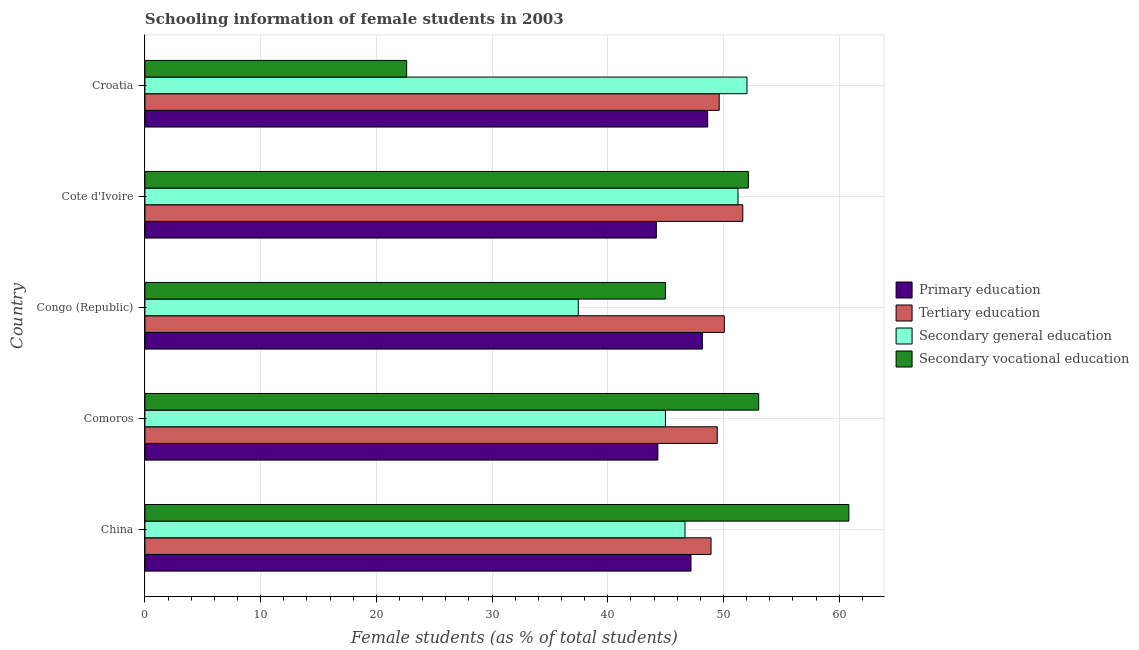How many groups of bars are there?
Your answer should be very brief. 5. Are the number of bars on each tick of the Y-axis equal?
Give a very brief answer. Yes. How many bars are there on the 1st tick from the top?
Provide a short and direct response. 4. How many bars are there on the 2nd tick from the bottom?
Your answer should be compact. 4. What is the percentage of female students in secondary education in Congo (Republic)?
Offer a very short reply. 37.45. Across all countries, what is the maximum percentage of female students in tertiary education?
Keep it short and to the point. 51.67. Across all countries, what is the minimum percentage of female students in secondary education?
Make the answer very short. 37.45. In which country was the percentage of female students in tertiary education maximum?
Keep it short and to the point. Cote d'Ivoire. In which country was the percentage of female students in secondary education minimum?
Provide a succinct answer. Congo (Republic). What is the total percentage of female students in secondary education in the graph?
Ensure brevity in your answer.  232.4. What is the difference between the percentage of female students in secondary vocational education in Congo (Republic) and that in Cote d'Ivoire?
Keep it short and to the point. -7.17. What is the difference between the percentage of female students in secondary education in Croatia and the percentage of female students in tertiary education in Comoros?
Your answer should be very brief. 2.57. What is the average percentage of female students in tertiary education per country?
Ensure brevity in your answer.  49.95. What is the difference between the percentage of female students in secondary education and percentage of female students in tertiary education in China?
Give a very brief answer. -2.25. In how many countries, is the percentage of female students in primary education greater than 6 %?
Your answer should be very brief. 5. What is the difference between the highest and the second highest percentage of female students in tertiary education?
Provide a short and direct response. 1.6. What is the difference between the highest and the lowest percentage of female students in tertiary education?
Make the answer very short. 2.74. In how many countries, is the percentage of female students in tertiary education greater than the average percentage of female students in tertiary education taken over all countries?
Your answer should be very brief. 2. Is the sum of the percentage of female students in tertiary education in Congo (Republic) and Cote d'Ivoire greater than the maximum percentage of female students in secondary vocational education across all countries?
Make the answer very short. Yes. Is it the case that in every country, the sum of the percentage of female students in secondary vocational education and percentage of female students in primary education is greater than the sum of percentage of female students in tertiary education and percentage of female students in secondary education?
Your answer should be compact. Yes. What does the 4th bar from the top in Congo (Republic) represents?
Your answer should be compact. Primary education. What does the 1st bar from the bottom in Croatia represents?
Offer a very short reply. Primary education. Is it the case that in every country, the sum of the percentage of female students in primary education and percentage of female students in tertiary education is greater than the percentage of female students in secondary education?
Provide a short and direct response. Yes. Are all the bars in the graph horizontal?
Offer a terse response. Yes. What is the difference between two consecutive major ticks on the X-axis?
Your response must be concise. 10. Does the graph contain grids?
Your answer should be very brief. Yes. Where does the legend appear in the graph?
Provide a short and direct response. Center right. What is the title of the graph?
Keep it short and to the point. Schooling information of female students in 2003. Does "Austria" appear as one of the legend labels in the graph?
Offer a very short reply. No. What is the label or title of the X-axis?
Ensure brevity in your answer.  Female students (as % of total students). What is the Female students (as % of total students) of Primary education in China?
Provide a short and direct response. 47.19. What is the Female students (as % of total students) of Tertiary education in China?
Keep it short and to the point. 48.93. What is the Female students (as % of total students) in Secondary general education in China?
Provide a short and direct response. 46.68. What is the Female students (as % of total students) in Secondary vocational education in China?
Provide a short and direct response. 60.84. What is the Female students (as % of total students) in Primary education in Comoros?
Keep it short and to the point. 44.33. What is the Female students (as % of total students) of Tertiary education in Comoros?
Offer a terse response. 49.46. What is the Female students (as % of total students) in Secondary general education in Comoros?
Offer a terse response. 44.99. What is the Female students (as % of total students) of Secondary vocational education in Comoros?
Keep it short and to the point. 53.04. What is the Female students (as % of total students) in Primary education in Congo (Republic)?
Offer a terse response. 48.18. What is the Female students (as % of total students) of Tertiary education in Congo (Republic)?
Your answer should be very brief. 50.07. What is the Female students (as % of total students) in Secondary general education in Congo (Republic)?
Your answer should be very brief. 37.45. What is the Female students (as % of total students) of Secondary vocational education in Congo (Republic)?
Provide a succinct answer. 44.98. What is the Female students (as % of total students) of Primary education in Cote d'Ivoire?
Ensure brevity in your answer.  44.2. What is the Female students (as % of total students) of Tertiary education in Cote d'Ivoire?
Give a very brief answer. 51.67. What is the Female students (as % of total students) in Secondary general education in Cote d'Ivoire?
Your answer should be compact. 51.26. What is the Female students (as % of total students) of Secondary vocational education in Cote d'Ivoire?
Your response must be concise. 52.15. What is the Female students (as % of total students) in Primary education in Croatia?
Provide a succinct answer. 48.63. What is the Female students (as % of total students) of Tertiary education in Croatia?
Ensure brevity in your answer.  49.63. What is the Female students (as % of total students) of Secondary general education in Croatia?
Your answer should be compact. 52.03. What is the Female students (as % of total students) of Secondary vocational education in Croatia?
Your response must be concise. 22.62. Across all countries, what is the maximum Female students (as % of total students) in Primary education?
Offer a terse response. 48.63. Across all countries, what is the maximum Female students (as % of total students) of Tertiary education?
Your answer should be very brief. 51.67. Across all countries, what is the maximum Female students (as % of total students) of Secondary general education?
Your answer should be very brief. 52.03. Across all countries, what is the maximum Female students (as % of total students) of Secondary vocational education?
Give a very brief answer. 60.84. Across all countries, what is the minimum Female students (as % of total students) in Primary education?
Provide a short and direct response. 44.2. Across all countries, what is the minimum Female students (as % of total students) in Tertiary education?
Give a very brief answer. 48.93. Across all countries, what is the minimum Female students (as % of total students) in Secondary general education?
Offer a very short reply. 37.45. Across all countries, what is the minimum Female students (as % of total students) of Secondary vocational education?
Keep it short and to the point. 22.62. What is the total Female students (as % of total students) in Primary education in the graph?
Your answer should be very brief. 232.53. What is the total Female students (as % of total students) in Tertiary education in the graph?
Your answer should be very brief. 249.76. What is the total Female students (as % of total students) of Secondary general education in the graph?
Provide a short and direct response. 232.4. What is the total Female students (as % of total students) in Secondary vocational education in the graph?
Ensure brevity in your answer.  233.64. What is the difference between the Female students (as % of total students) in Primary education in China and that in Comoros?
Provide a short and direct response. 2.86. What is the difference between the Female students (as % of total students) in Tertiary education in China and that in Comoros?
Keep it short and to the point. -0.54. What is the difference between the Female students (as % of total students) of Secondary general education in China and that in Comoros?
Provide a short and direct response. 1.69. What is the difference between the Female students (as % of total students) in Secondary vocational education in China and that in Comoros?
Your response must be concise. 7.79. What is the difference between the Female students (as % of total students) in Primary education in China and that in Congo (Republic)?
Give a very brief answer. -0.98. What is the difference between the Female students (as % of total students) of Tertiary education in China and that in Congo (Republic)?
Ensure brevity in your answer.  -1.15. What is the difference between the Female students (as % of total students) in Secondary general education in China and that in Congo (Republic)?
Offer a terse response. 9.22. What is the difference between the Female students (as % of total students) of Secondary vocational education in China and that in Congo (Republic)?
Provide a short and direct response. 15.85. What is the difference between the Female students (as % of total students) in Primary education in China and that in Cote d'Ivoire?
Provide a short and direct response. 2.99. What is the difference between the Female students (as % of total students) of Tertiary education in China and that in Cote d'Ivoire?
Your answer should be very brief. -2.74. What is the difference between the Female students (as % of total students) of Secondary general education in China and that in Cote d'Ivoire?
Keep it short and to the point. -4.58. What is the difference between the Female students (as % of total students) in Secondary vocational education in China and that in Cote d'Ivoire?
Offer a terse response. 8.68. What is the difference between the Female students (as % of total students) in Primary education in China and that in Croatia?
Provide a short and direct response. -1.44. What is the difference between the Female students (as % of total students) in Tertiary education in China and that in Croatia?
Offer a very short reply. -0.7. What is the difference between the Female students (as % of total students) of Secondary general education in China and that in Croatia?
Make the answer very short. -5.36. What is the difference between the Female students (as % of total students) of Secondary vocational education in China and that in Croatia?
Your response must be concise. 38.22. What is the difference between the Female students (as % of total students) in Primary education in Comoros and that in Congo (Republic)?
Provide a short and direct response. -3.85. What is the difference between the Female students (as % of total students) in Tertiary education in Comoros and that in Congo (Republic)?
Keep it short and to the point. -0.61. What is the difference between the Female students (as % of total students) of Secondary general education in Comoros and that in Congo (Republic)?
Your answer should be compact. 7.53. What is the difference between the Female students (as % of total students) of Secondary vocational education in Comoros and that in Congo (Republic)?
Give a very brief answer. 8.06. What is the difference between the Female students (as % of total students) in Primary education in Comoros and that in Cote d'Ivoire?
Offer a terse response. 0.13. What is the difference between the Female students (as % of total students) of Tertiary education in Comoros and that in Cote d'Ivoire?
Keep it short and to the point. -2.21. What is the difference between the Female students (as % of total students) in Secondary general education in Comoros and that in Cote d'Ivoire?
Provide a succinct answer. -6.27. What is the difference between the Female students (as % of total students) of Secondary vocational education in Comoros and that in Cote d'Ivoire?
Your response must be concise. 0.89. What is the difference between the Female students (as % of total students) of Primary education in Comoros and that in Croatia?
Your answer should be very brief. -4.3. What is the difference between the Female students (as % of total students) in Tertiary education in Comoros and that in Croatia?
Provide a succinct answer. -0.17. What is the difference between the Female students (as % of total students) of Secondary general education in Comoros and that in Croatia?
Your answer should be compact. -7.05. What is the difference between the Female students (as % of total students) in Secondary vocational education in Comoros and that in Croatia?
Offer a very short reply. 30.42. What is the difference between the Female students (as % of total students) of Primary education in Congo (Republic) and that in Cote d'Ivoire?
Provide a short and direct response. 3.98. What is the difference between the Female students (as % of total students) of Tertiary education in Congo (Republic) and that in Cote d'Ivoire?
Give a very brief answer. -1.6. What is the difference between the Female students (as % of total students) of Secondary general education in Congo (Republic) and that in Cote d'Ivoire?
Give a very brief answer. -13.8. What is the difference between the Female students (as % of total students) of Secondary vocational education in Congo (Republic) and that in Cote d'Ivoire?
Make the answer very short. -7.17. What is the difference between the Female students (as % of total students) in Primary education in Congo (Republic) and that in Croatia?
Provide a succinct answer. -0.46. What is the difference between the Female students (as % of total students) of Tertiary education in Congo (Republic) and that in Croatia?
Make the answer very short. 0.44. What is the difference between the Female students (as % of total students) in Secondary general education in Congo (Republic) and that in Croatia?
Your answer should be very brief. -14.58. What is the difference between the Female students (as % of total students) in Secondary vocational education in Congo (Republic) and that in Croatia?
Provide a succinct answer. 22.36. What is the difference between the Female students (as % of total students) in Primary education in Cote d'Ivoire and that in Croatia?
Make the answer very short. -4.43. What is the difference between the Female students (as % of total students) in Tertiary education in Cote d'Ivoire and that in Croatia?
Make the answer very short. 2.04. What is the difference between the Female students (as % of total students) in Secondary general education in Cote d'Ivoire and that in Croatia?
Give a very brief answer. -0.78. What is the difference between the Female students (as % of total students) of Secondary vocational education in Cote d'Ivoire and that in Croatia?
Your answer should be compact. 29.54. What is the difference between the Female students (as % of total students) in Primary education in China and the Female students (as % of total students) in Tertiary education in Comoros?
Your answer should be compact. -2.27. What is the difference between the Female students (as % of total students) in Primary education in China and the Female students (as % of total students) in Secondary general education in Comoros?
Make the answer very short. 2.21. What is the difference between the Female students (as % of total students) in Primary education in China and the Female students (as % of total students) in Secondary vocational education in Comoros?
Your answer should be very brief. -5.85. What is the difference between the Female students (as % of total students) in Tertiary education in China and the Female students (as % of total students) in Secondary general education in Comoros?
Ensure brevity in your answer.  3.94. What is the difference between the Female students (as % of total students) in Tertiary education in China and the Female students (as % of total students) in Secondary vocational education in Comoros?
Your response must be concise. -4.12. What is the difference between the Female students (as % of total students) in Secondary general education in China and the Female students (as % of total students) in Secondary vocational education in Comoros?
Provide a succinct answer. -6.37. What is the difference between the Female students (as % of total students) in Primary education in China and the Female students (as % of total students) in Tertiary education in Congo (Republic)?
Ensure brevity in your answer.  -2.88. What is the difference between the Female students (as % of total students) of Primary education in China and the Female students (as % of total students) of Secondary general education in Congo (Republic)?
Your answer should be compact. 9.74. What is the difference between the Female students (as % of total students) of Primary education in China and the Female students (as % of total students) of Secondary vocational education in Congo (Republic)?
Your response must be concise. 2.21. What is the difference between the Female students (as % of total students) of Tertiary education in China and the Female students (as % of total students) of Secondary general education in Congo (Republic)?
Provide a succinct answer. 11.47. What is the difference between the Female students (as % of total students) in Tertiary education in China and the Female students (as % of total students) in Secondary vocational education in Congo (Republic)?
Ensure brevity in your answer.  3.94. What is the difference between the Female students (as % of total students) of Secondary general education in China and the Female students (as % of total students) of Secondary vocational education in Congo (Republic)?
Keep it short and to the point. 1.69. What is the difference between the Female students (as % of total students) of Primary education in China and the Female students (as % of total students) of Tertiary education in Cote d'Ivoire?
Keep it short and to the point. -4.48. What is the difference between the Female students (as % of total students) in Primary education in China and the Female students (as % of total students) in Secondary general education in Cote d'Ivoire?
Provide a short and direct response. -4.06. What is the difference between the Female students (as % of total students) of Primary education in China and the Female students (as % of total students) of Secondary vocational education in Cote d'Ivoire?
Give a very brief answer. -4.96. What is the difference between the Female students (as % of total students) in Tertiary education in China and the Female students (as % of total students) in Secondary general education in Cote d'Ivoire?
Your response must be concise. -2.33. What is the difference between the Female students (as % of total students) of Tertiary education in China and the Female students (as % of total students) of Secondary vocational education in Cote d'Ivoire?
Provide a short and direct response. -3.23. What is the difference between the Female students (as % of total students) of Secondary general education in China and the Female students (as % of total students) of Secondary vocational education in Cote d'Ivoire?
Make the answer very short. -5.48. What is the difference between the Female students (as % of total students) of Primary education in China and the Female students (as % of total students) of Tertiary education in Croatia?
Provide a short and direct response. -2.44. What is the difference between the Female students (as % of total students) of Primary education in China and the Female students (as % of total students) of Secondary general education in Croatia?
Offer a very short reply. -4.84. What is the difference between the Female students (as % of total students) of Primary education in China and the Female students (as % of total students) of Secondary vocational education in Croatia?
Offer a terse response. 24.57. What is the difference between the Female students (as % of total students) in Tertiary education in China and the Female students (as % of total students) in Secondary general education in Croatia?
Your answer should be very brief. -3.1. What is the difference between the Female students (as % of total students) of Tertiary education in China and the Female students (as % of total students) of Secondary vocational education in Croatia?
Make the answer very short. 26.31. What is the difference between the Female students (as % of total students) of Secondary general education in China and the Female students (as % of total students) of Secondary vocational education in Croatia?
Make the answer very short. 24.06. What is the difference between the Female students (as % of total students) of Primary education in Comoros and the Female students (as % of total students) of Tertiary education in Congo (Republic)?
Ensure brevity in your answer.  -5.74. What is the difference between the Female students (as % of total students) of Primary education in Comoros and the Female students (as % of total students) of Secondary general education in Congo (Republic)?
Provide a short and direct response. 6.88. What is the difference between the Female students (as % of total students) in Primary education in Comoros and the Female students (as % of total students) in Secondary vocational education in Congo (Republic)?
Offer a terse response. -0.65. What is the difference between the Female students (as % of total students) of Tertiary education in Comoros and the Female students (as % of total students) of Secondary general education in Congo (Republic)?
Offer a terse response. 12.01. What is the difference between the Female students (as % of total students) of Tertiary education in Comoros and the Female students (as % of total students) of Secondary vocational education in Congo (Republic)?
Offer a terse response. 4.48. What is the difference between the Female students (as % of total students) in Secondary general education in Comoros and the Female students (as % of total students) in Secondary vocational education in Congo (Republic)?
Offer a terse response. 0. What is the difference between the Female students (as % of total students) of Primary education in Comoros and the Female students (as % of total students) of Tertiary education in Cote d'Ivoire?
Offer a very short reply. -7.34. What is the difference between the Female students (as % of total students) in Primary education in Comoros and the Female students (as % of total students) in Secondary general education in Cote d'Ivoire?
Your response must be concise. -6.92. What is the difference between the Female students (as % of total students) in Primary education in Comoros and the Female students (as % of total students) in Secondary vocational education in Cote d'Ivoire?
Provide a succinct answer. -7.82. What is the difference between the Female students (as % of total students) of Tertiary education in Comoros and the Female students (as % of total students) of Secondary general education in Cote d'Ivoire?
Your answer should be very brief. -1.79. What is the difference between the Female students (as % of total students) of Tertiary education in Comoros and the Female students (as % of total students) of Secondary vocational education in Cote d'Ivoire?
Ensure brevity in your answer.  -2.69. What is the difference between the Female students (as % of total students) of Secondary general education in Comoros and the Female students (as % of total students) of Secondary vocational education in Cote d'Ivoire?
Offer a very short reply. -7.17. What is the difference between the Female students (as % of total students) of Primary education in Comoros and the Female students (as % of total students) of Secondary general education in Croatia?
Ensure brevity in your answer.  -7.7. What is the difference between the Female students (as % of total students) in Primary education in Comoros and the Female students (as % of total students) in Secondary vocational education in Croatia?
Offer a terse response. 21.71. What is the difference between the Female students (as % of total students) of Tertiary education in Comoros and the Female students (as % of total students) of Secondary general education in Croatia?
Provide a short and direct response. -2.57. What is the difference between the Female students (as % of total students) of Tertiary education in Comoros and the Female students (as % of total students) of Secondary vocational education in Croatia?
Offer a very short reply. 26.84. What is the difference between the Female students (as % of total students) in Secondary general education in Comoros and the Female students (as % of total students) in Secondary vocational education in Croatia?
Make the answer very short. 22.37. What is the difference between the Female students (as % of total students) of Primary education in Congo (Republic) and the Female students (as % of total students) of Tertiary education in Cote d'Ivoire?
Make the answer very short. -3.49. What is the difference between the Female students (as % of total students) in Primary education in Congo (Republic) and the Female students (as % of total students) in Secondary general education in Cote d'Ivoire?
Give a very brief answer. -3.08. What is the difference between the Female students (as % of total students) in Primary education in Congo (Republic) and the Female students (as % of total students) in Secondary vocational education in Cote d'Ivoire?
Your answer should be very brief. -3.98. What is the difference between the Female students (as % of total students) of Tertiary education in Congo (Republic) and the Female students (as % of total students) of Secondary general education in Cote d'Ivoire?
Keep it short and to the point. -1.18. What is the difference between the Female students (as % of total students) in Tertiary education in Congo (Republic) and the Female students (as % of total students) in Secondary vocational education in Cote d'Ivoire?
Give a very brief answer. -2.08. What is the difference between the Female students (as % of total students) of Secondary general education in Congo (Republic) and the Female students (as % of total students) of Secondary vocational education in Cote d'Ivoire?
Provide a succinct answer. -14.7. What is the difference between the Female students (as % of total students) of Primary education in Congo (Republic) and the Female students (as % of total students) of Tertiary education in Croatia?
Provide a short and direct response. -1.45. What is the difference between the Female students (as % of total students) of Primary education in Congo (Republic) and the Female students (as % of total students) of Secondary general education in Croatia?
Your answer should be compact. -3.86. What is the difference between the Female students (as % of total students) in Primary education in Congo (Republic) and the Female students (as % of total students) in Secondary vocational education in Croatia?
Provide a succinct answer. 25.56. What is the difference between the Female students (as % of total students) in Tertiary education in Congo (Republic) and the Female students (as % of total students) in Secondary general education in Croatia?
Keep it short and to the point. -1.96. What is the difference between the Female students (as % of total students) of Tertiary education in Congo (Republic) and the Female students (as % of total students) of Secondary vocational education in Croatia?
Make the answer very short. 27.45. What is the difference between the Female students (as % of total students) of Secondary general education in Congo (Republic) and the Female students (as % of total students) of Secondary vocational education in Croatia?
Provide a short and direct response. 14.83. What is the difference between the Female students (as % of total students) in Primary education in Cote d'Ivoire and the Female students (as % of total students) in Tertiary education in Croatia?
Your answer should be very brief. -5.43. What is the difference between the Female students (as % of total students) in Primary education in Cote d'Ivoire and the Female students (as % of total students) in Secondary general education in Croatia?
Your answer should be very brief. -7.83. What is the difference between the Female students (as % of total students) in Primary education in Cote d'Ivoire and the Female students (as % of total students) in Secondary vocational education in Croatia?
Give a very brief answer. 21.58. What is the difference between the Female students (as % of total students) in Tertiary education in Cote d'Ivoire and the Female students (as % of total students) in Secondary general education in Croatia?
Your answer should be very brief. -0.36. What is the difference between the Female students (as % of total students) of Tertiary education in Cote d'Ivoire and the Female students (as % of total students) of Secondary vocational education in Croatia?
Give a very brief answer. 29.05. What is the difference between the Female students (as % of total students) in Secondary general education in Cote d'Ivoire and the Female students (as % of total students) in Secondary vocational education in Croatia?
Your answer should be compact. 28.64. What is the average Female students (as % of total students) of Primary education per country?
Ensure brevity in your answer.  46.51. What is the average Female students (as % of total students) of Tertiary education per country?
Keep it short and to the point. 49.95. What is the average Female students (as % of total students) in Secondary general education per country?
Ensure brevity in your answer.  46.48. What is the average Female students (as % of total students) in Secondary vocational education per country?
Your answer should be very brief. 46.73. What is the difference between the Female students (as % of total students) in Primary education and Female students (as % of total students) in Tertiary education in China?
Provide a short and direct response. -1.74. What is the difference between the Female students (as % of total students) of Primary education and Female students (as % of total students) of Secondary general education in China?
Your answer should be very brief. 0.51. What is the difference between the Female students (as % of total students) of Primary education and Female students (as % of total students) of Secondary vocational education in China?
Provide a short and direct response. -13.65. What is the difference between the Female students (as % of total students) in Tertiary education and Female students (as % of total students) in Secondary general education in China?
Give a very brief answer. 2.25. What is the difference between the Female students (as % of total students) of Tertiary education and Female students (as % of total students) of Secondary vocational education in China?
Give a very brief answer. -11.91. What is the difference between the Female students (as % of total students) in Secondary general education and Female students (as % of total students) in Secondary vocational education in China?
Offer a terse response. -14.16. What is the difference between the Female students (as % of total students) of Primary education and Female students (as % of total students) of Tertiary education in Comoros?
Ensure brevity in your answer.  -5.13. What is the difference between the Female students (as % of total students) in Primary education and Female students (as % of total students) in Secondary general education in Comoros?
Make the answer very short. -0.66. What is the difference between the Female students (as % of total students) in Primary education and Female students (as % of total students) in Secondary vocational education in Comoros?
Provide a short and direct response. -8.71. What is the difference between the Female students (as % of total students) of Tertiary education and Female students (as % of total students) of Secondary general education in Comoros?
Offer a terse response. 4.48. What is the difference between the Female students (as % of total students) in Tertiary education and Female students (as % of total students) in Secondary vocational education in Comoros?
Provide a succinct answer. -3.58. What is the difference between the Female students (as % of total students) in Secondary general education and Female students (as % of total students) in Secondary vocational education in Comoros?
Make the answer very short. -8.06. What is the difference between the Female students (as % of total students) of Primary education and Female students (as % of total students) of Tertiary education in Congo (Republic)?
Provide a succinct answer. -1.9. What is the difference between the Female students (as % of total students) of Primary education and Female students (as % of total students) of Secondary general education in Congo (Republic)?
Provide a short and direct response. 10.72. What is the difference between the Female students (as % of total students) of Primary education and Female students (as % of total students) of Secondary vocational education in Congo (Republic)?
Your response must be concise. 3.19. What is the difference between the Female students (as % of total students) of Tertiary education and Female students (as % of total students) of Secondary general education in Congo (Republic)?
Provide a short and direct response. 12.62. What is the difference between the Female students (as % of total students) of Tertiary education and Female students (as % of total students) of Secondary vocational education in Congo (Republic)?
Provide a succinct answer. 5.09. What is the difference between the Female students (as % of total students) of Secondary general education and Female students (as % of total students) of Secondary vocational education in Congo (Republic)?
Your response must be concise. -7.53. What is the difference between the Female students (as % of total students) in Primary education and Female students (as % of total students) in Tertiary education in Cote d'Ivoire?
Ensure brevity in your answer.  -7.47. What is the difference between the Female students (as % of total students) of Primary education and Female students (as % of total students) of Secondary general education in Cote d'Ivoire?
Make the answer very short. -7.06. What is the difference between the Female students (as % of total students) of Primary education and Female students (as % of total students) of Secondary vocational education in Cote d'Ivoire?
Keep it short and to the point. -7.96. What is the difference between the Female students (as % of total students) in Tertiary education and Female students (as % of total students) in Secondary general education in Cote d'Ivoire?
Your answer should be compact. 0.41. What is the difference between the Female students (as % of total students) in Tertiary education and Female students (as % of total students) in Secondary vocational education in Cote d'Ivoire?
Make the answer very short. -0.48. What is the difference between the Female students (as % of total students) in Secondary general education and Female students (as % of total students) in Secondary vocational education in Cote d'Ivoire?
Provide a succinct answer. -0.9. What is the difference between the Female students (as % of total students) in Primary education and Female students (as % of total students) in Tertiary education in Croatia?
Ensure brevity in your answer.  -1. What is the difference between the Female students (as % of total students) of Primary education and Female students (as % of total students) of Secondary general education in Croatia?
Your answer should be compact. -3.4. What is the difference between the Female students (as % of total students) in Primary education and Female students (as % of total students) in Secondary vocational education in Croatia?
Offer a very short reply. 26.01. What is the difference between the Female students (as % of total students) of Tertiary education and Female students (as % of total students) of Secondary general education in Croatia?
Provide a succinct answer. -2.4. What is the difference between the Female students (as % of total students) of Tertiary education and Female students (as % of total students) of Secondary vocational education in Croatia?
Provide a succinct answer. 27.01. What is the difference between the Female students (as % of total students) in Secondary general education and Female students (as % of total students) in Secondary vocational education in Croatia?
Ensure brevity in your answer.  29.41. What is the ratio of the Female students (as % of total students) in Primary education in China to that in Comoros?
Offer a terse response. 1.06. What is the ratio of the Female students (as % of total students) of Tertiary education in China to that in Comoros?
Provide a short and direct response. 0.99. What is the ratio of the Female students (as % of total students) in Secondary general education in China to that in Comoros?
Offer a very short reply. 1.04. What is the ratio of the Female students (as % of total students) in Secondary vocational education in China to that in Comoros?
Your answer should be compact. 1.15. What is the ratio of the Female students (as % of total students) in Primary education in China to that in Congo (Republic)?
Provide a succinct answer. 0.98. What is the ratio of the Female students (as % of total students) of Tertiary education in China to that in Congo (Republic)?
Offer a very short reply. 0.98. What is the ratio of the Female students (as % of total students) of Secondary general education in China to that in Congo (Republic)?
Ensure brevity in your answer.  1.25. What is the ratio of the Female students (as % of total students) of Secondary vocational education in China to that in Congo (Republic)?
Provide a succinct answer. 1.35. What is the ratio of the Female students (as % of total students) in Primary education in China to that in Cote d'Ivoire?
Offer a very short reply. 1.07. What is the ratio of the Female students (as % of total students) of Tertiary education in China to that in Cote d'Ivoire?
Provide a short and direct response. 0.95. What is the ratio of the Female students (as % of total students) of Secondary general education in China to that in Cote d'Ivoire?
Offer a terse response. 0.91. What is the ratio of the Female students (as % of total students) in Secondary vocational education in China to that in Cote d'Ivoire?
Offer a very short reply. 1.17. What is the ratio of the Female students (as % of total students) of Primary education in China to that in Croatia?
Your answer should be compact. 0.97. What is the ratio of the Female students (as % of total students) of Tertiary education in China to that in Croatia?
Your response must be concise. 0.99. What is the ratio of the Female students (as % of total students) in Secondary general education in China to that in Croatia?
Keep it short and to the point. 0.9. What is the ratio of the Female students (as % of total students) of Secondary vocational education in China to that in Croatia?
Provide a succinct answer. 2.69. What is the ratio of the Female students (as % of total students) in Primary education in Comoros to that in Congo (Republic)?
Make the answer very short. 0.92. What is the ratio of the Female students (as % of total students) in Secondary general education in Comoros to that in Congo (Republic)?
Ensure brevity in your answer.  1.2. What is the ratio of the Female students (as % of total students) of Secondary vocational education in Comoros to that in Congo (Republic)?
Provide a succinct answer. 1.18. What is the ratio of the Female students (as % of total students) in Tertiary education in Comoros to that in Cote d'Ivoire?
Your response must be concise. 0.96. What is the ratio of the Female students (as % of total students) in Secondary general education in Comoros to that in Cote d'Ivoire?
Offer a very short reply. 0.88. What is the ratio of the Female students (as % of total students) of Primary education in Comoros to that in Croatia?
Your answer should be very brief. 0.91. What is the ratio of the Female students (as % of total students) in Tertiary education in Comoros to that in Croatia?
Your response must be concise. 1. What is the ratio of the Female students (as % of total students) in Secondary general education in Comoros to that in Croatia?
Provide a short and direct response. 0.86. What is the ratio of the Female students (as % of total students) in Secondary vocational education in Comoros to that in Croatia?
Your response must be concise. 2.35. What is the ratio of the Female students (as % of total students) of Primary education in Congo (Republic) to that in Cote d'Ivoire?
Your answer should be compact. 1.09. What is the ratio of the Female students (as % of total students) in Tertiary education in Congo (Republic) to that in Cote d'Ivoire?
Your answer should be very brief. 0.97. What is the ratio of the Female students (as % of total students) in Secondary general education in Congo (Republic) to that in Cote d'Ivoire?
Ensure brevity in your answer.  0.73. What is the ratio of the Female students (as % of total students) of Secondary vocational education in Congo (Republic) to that in Cote d'Ivoire?
Your response must be concise. 0.86. What is the ratio of the Female students (as % of total students) in Primary education in Congo (Republic) to that in Croatia?
Offer a terse response. 0.99. What is the ratio of the Female students (as % of total students) of Tertiary education in Congo (Republic) to that in Croatia?
Ensure brevity in your answer.  1.01. What is the ratio of the Female students (as % of total students) of Secondary general education in Congo (Republic) to that in Croatia?
Offer a very short reply. 0.72. What is the ratio of the Female students (as % of total students) of Secondary vocational education in Congo (Republic) to that in Croatia?
Your response must be concise. 1.99. What is the ratio of the Female students (as % of total students) in Primary education in Cote d'Ivoire to that in Croatia?
Keep it short and to the point. 0.91. What is the ratio of the Female students (as % of total students) in Tertiary education in Cote d'Ivoire to that in Croatia?
Your answer should be very brief. 1.04. What is the ratio of the Female students (as % of total students) in Secondary general education in Cote d'Ivoire to that in Croatia?
Your response must be concise. 0.99. What is the ratio of the Female students (as % of total students) in Secondary vocational education in Cote d'Ivoire to that in Croatia?
Your response must be concise. 2.31. What is the difference between the highest and the second highest Female students (as % of total students) of Primary education?
Your answer should be very brief. 0.46. What is the difference between the highest and the second highest Female students (as % of total students) in Tertiary education?
Ensure brevity in your answer.  1.6. What is the difference between the highest and the second highest Female students (as % of total students) of Secondary general education?
Offer a terse response. 0.78. What is the difference between the highest and the second highest Female students (as % of total students) in Secondary vocational education?
Offer a very short reply. 7.79. What is the difference between the highest and the lowest Female students (as % of total students) of Primary education?
Keep it short and to the point. 4.43. What is the difference between the highest and the lowest Female students (as % of total students) of Tertiary education?
Ensure brevity in your answer.  2.74. What is the difference between the highest and the lowest Female students (as % of total students) of Secondary general education?
Make the answer very short. 14.58. What is the difference between the highest and the lowest Female students (as % of total students) in Secondary vocational education?
Your answer should be very brief. 38.22. 